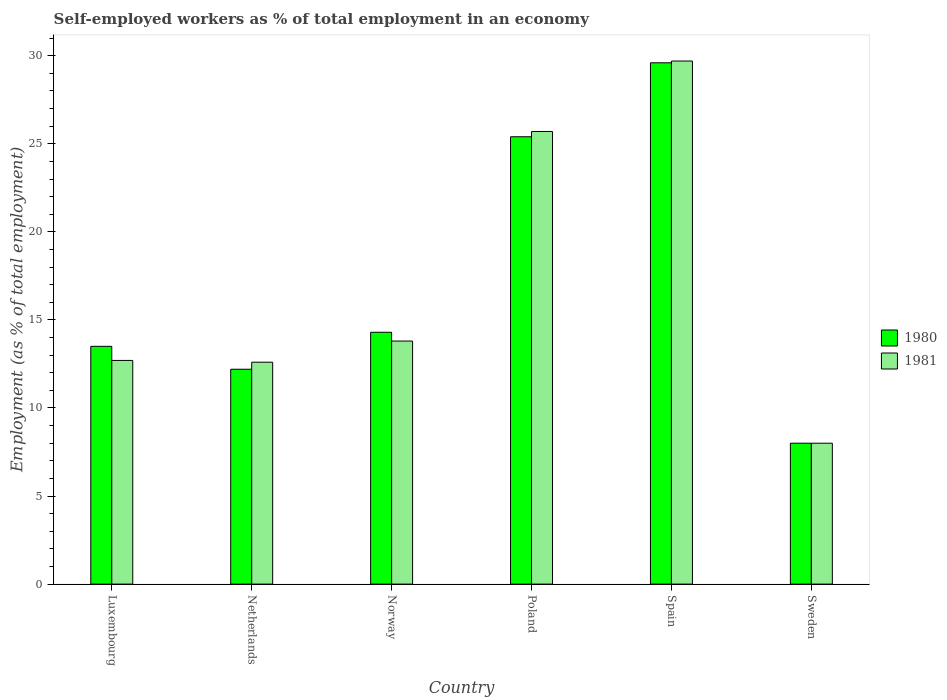How many bars are there on the 5th tick from the right?
Your answer should be compact. 2. In how many cases, is the number of bars for a given country not equal to the number of legend labels?
Give a very brief answer. 0. What is the percentage of self-employed workers in 1980 in Luxembourg?
Provide a succinct answer. 13.5. Across all countries, what is the maximum percentage of self-employed workers in 1981?
Give a very brief answer. 29.7. In which country was the percentage of self-employed workers in 1981 maximum?
Your answer should be very brief. Spain. In which country was the percentage of self-employed workers in 1981 minimum?
Ensure brevity in your answer.  Sweden. What is the total percentage of self-employed workers in 1981 in the graph?
Give a very brief answer. 102.5. What is the difference between the percentage of self-employed workers in 1981 in Luxembourg and that in Norway?
Your answer should be compact. -1.1. What is the difference between the percentage of self-employed workers in 1981 in Netherlands and the percentage of self-employed workers in 1980 in Norway?
Make the answer very short. -1.7. What is the average percentage of self-employed workers in 1980 per country?
Your response must be concise. 17.17. What is the difference between the percentage of self-employed workers of/in 1980 and percentage of self-employed workers of/in 1981 in Poland?
Keep it short and to the point. -0.3. What is the ratio of the percentage of self-employed workers in 1980 in Netherlands to that in Poland?
Your answer should be compact. 0.48. Is the difference between the percentage of self-employed workers in 1980 in Luxembourg and Norway greater than the difference between the percentage of self-employed workers in 1981 in Luxembourg and Norway?
Provide a succinct answer. Yes. What is the difference between the highest and the second highest percentage of self-employed workers in 1981?
Ensure brevity in your answer.  11.9. What is the difference between the highest and the lowest percentage of self-employed workers in 1980?
Offer a very short reply. 21.6. Is the sum of the percentage of self-employed workers in 1981 in Poland and Spain greater than the maximum percentage of self-employed workers in 1980 across all countries?
Provide a short and direct response. Yes. What does the 2nd bar from the left in Norway represents?
Make the answer very short. 1981. Are all the bars in the graph horizontal?
Provide a succinct answer. No. Are the values on the major ticks of Y-axis written in scientific E-notation?
Provide a short and direct response. No. Does the graph contain grids?
Provide a short and direct response. No. How are the legend labels stacked?
Provide a succinct answer. Vertical. What is the title of the graph?
Your answer should be compact. Self-employed workers as % of total employment in an economy. What is the label or title of the X-axis?
Offer a very short reply. Country. What is the label or title of the Y-axis?
Make the answer very short. Employment (as % of total employment). What is the Employment (as % of total employment) in 1980 in Luxembourg?
Give a very brief answer. 13.5. What is the Employment (as % of total employment) of 1981 in Luxembourg?
Ensure brevity in your answer.  12.7. What is the Employment (as % of total employment) of 1980 in Netherlands?
Offer a terse response. 12.2. What is the Employment (as % of total employment) of 1981 in Netherlands?
Offer a very short reply. 12.6. What is the Employment (as % of total employment) of 1980 in Norway?
Your response must be concise. 14.3. What is the Employment (as % of total employment) of 1981 in Norway?
Your response must be concise. 13.8. What is the Employment (as % of total employment) in 1980 in Poland?
Offer a very short reply. 25.4. What is the Employment (as % of total employment) in 1981 in Poland?
Your answer should be very brief. 25.7. What is the Employment (as % of total employment) in 1980 in Spain?
Provide a short and direct response. 29.6. What is the Employment (as % of total employment) of 1981 in Spain?
Offer a terse response. 29.7. What is the Employment (as % of total employment) of 1980 in Sweden?
Give a very brief answer. 8. What is the Employment (as % of total employment) in 1981 in Sweden?
Provide a short and direct response. 8. Across all countries, what is the maximum Employment (as % of total employment) in 1980?
Your response must be concise. 29.6. Across all countries, what is the maximum Employment (as % of total employment) of 1981?
Your response must be concise. 29.7. What is the total Employment (as % of total employment) of 1980 in the graph?
Offer a very short reply. 103. What is the total Employment (as % of total employment) in 1981 in the graph?
Ensure brevity in your answer.  102.5. What is the difference between the Employment (as % of total employment) in 1981 in Luxembourg and that in Netherlands?
Provide a succinct answer. 0.1. What is the difference between the Employment (as % of total employment) of 1980 in Luxembourg and that in Poland?
Keep it short and to the point. -11.9. What is the difference between the Employment (as % of total employment) of 1980 in Luxembourg and that in Spain?
Provide a short and direct response. -16.1. What is the difference between the Employment (as % of total employment) of 1981 in Luxembourg and that in Spain?
Your response must be concise. -17. What is the difference between the Employment (as % of total employment) in 1981 in Luxembourg and that in Sweden?
Offer a very short reply. 4.7. What is the difference between the Employment (as % of total employment) of 1980 in Netherlands and that in Norway?
Give a very brief answer. -2.1. What is the difference between the Employment (as % of total employment) in 1980 in Netherlands and that in Spain?
Your answer should be very brief. -17.4. What is the difference between the Employment (as % of total employment) of 1981 in Netherlands and that in Spain?
Offer a very short reply. -17.1. What is the difference between the Employment (as % of total employment) in 1980 in Norway and that in Spain?
Keep it short and to the point. -15.3. What is the difference between the Employment (as % of total employment) in 1981 in Norway and that in Spain?
Your answer should be compact. -15.9. What is the difference between the Employment (as % of total employment) of 1980 in Norway and that in Sweden?
Give a very brief answer. 6.3. What is the difference between the Employment (as % of total employment) of 1980 in Poland and that in Sweden?
Offer a very short reply. 17.4. What is the difference between the Employment (as % of total employment) in 1980 in Spain and that in Sweden?
Your answer should be very brief. 21.6. What is the difference between the Employment (as % of total employment) in 1981 in Spain and that in Sweden?
Provide a succinct answer. 21.7. What is the difference between the Employment (as % of total employment) in 1980 in Luxembourg and the Employment (as % of total employment) in 1981 in Spain?
Your answer should be very brief. -16.2. What is the difference between the Employment (as % of total employment) of 1980 in Luxembourg and the Employment (as % of total employment) of 1981 in Sweden?
Offer a terse response. 5.5. What is the difference between the Employment (as % of total employment) in 1980 in Netherlands and the Employment (as % of total employment) in 1981 in Norway?
Provide a succinct answer. -1.6. What is the difference between the Employment (as % of total employment) in 1980 in Netherlands and the Employment (as % of total employment) in 1981 in Spain?
Provide a succinct answer. -17.5. What is the difference between the Employment (as % of total employment) of 1980 in Norway and the Employment (as % of total employment) of 1981 in Spain?
Your response must be concise. -15.4. What is the difference between the Employment (as % of total employment) of 1980 in Norway and the Employment (as % of total employment) of 1981 in Sweden?
Keep it short and to the point. 6.3. What is the difference between the Employment (as % of total employment) of 1980 in Poland and the Employment (as % of total employment) of 1981 in Sweden?
Give a very brief answer. 17.4. What is the difference between the Employment (as % of total employment) in 1980 in Spain and the Employment (as % of total employment) in 1981 in Sweden?
Your response must be concise. 21.6. What is the average Employment (as % of total employment) in 1980 per country?
Your answer should be very brief. 17.17. What is the average Employment (as % of total employment) of 1981 per country?
Your answer should be compact. 17.08. What is the difference between the Employment (as % of total employment) in 1980 and Employment (as % of total employment) in 1981 in Poland?
Your response must be concise. -0.3. What is the difference between the Employment (as % of total employment) of 1980 and Employment (as % of total employment) of 1981 in Spain?
Keep it short and to the point. -0.1. What is the difference between the Employment (as % of total employment) in 1980 and Employment (as % of total employment) in 1981 in Sweden?
Ensure brevity in your answer.  0. What is the ratio of the Employment (as % of total employment) in 1980 in Luxembourg to that in Netherlands?
Your answer should be very brief. 1.11. What is the ratio of the Employment (as % of total employment) in 1981 in Luxembourg to that in Netherlands?
Your answer should be compact. 1.01. What is the ratio of the Employment (as % of total employment) of 1980 in Luxembourg to that in Norway?
Your answer should be compact. 0.94. What is the ratio of the Employment (as % of total employment) in 1981 in Luxembourg to that in Norway?
Keep it short and to the point. 0.92. What is the ratio of the Employment (as % of total employment) of 1980 in Luxembourg to that in Poland?
Ensure brevity in your answer.  0.53. What is the ratio of the Employment (as % of total employment) in 1981 in Luxembourg to that in Poland?
Your answer should be compact. 0.49. What is the ratio of the Employment (as % of total employment) in 1980 in Luxembourg to that in Spain?
Make the answer very short. 0.46. What is the ratio of the Employment (as % of total employment) of 1981 in Luxembourg to that in Spain?
Keep it short and to the point. 0.43. What is the ratio of the Employment (as % of total employment) of 1980 in Luxembourg to that in Sweden?
Your response must be concise. 1.69. What is the ratio of the Employment (as % of total employment) of 1981 in Luxembourg to that in Sweden?
Your answer should be very brief. 1.59. What is the ratio of the Employment (as % of total employment) of 1980 in Netherlands to that in Norway?
Offer a very short reply. 0.85. What is the ratio of the Employment (as % of total employment) in 1981 in Netherlands to that in Norway?
Your response must be concise. 0.91. What is the ratio of the Employment (as % of total employment) of 1980 in Netherlands to that in Poland?
Your answer should be very brief. 0.48. What is the ratio of the Employment (as % of total employment) of 1981 in Netherlands to that in Poland?
Your answer should be compact. 0.49. What is the ratio of the Employment (as % of total employment) in 1980 in Netherlands to that in Spain?
Give a very brief answer. 0.41. What is the ratio of the Employment (as % of total employment) of 1981 in Netherlands to that in Spain?
Offer a terse response. 0.42. What is the ratio of the Employment (as % of total employment) of 1980 in Netherlands to that in Sweden?
Ensure brevity in your answer.  1.52. What is the ratio of the Employment (as % of total employment) of 1981 in Netherlands to that in Sweden?
Give a very brief answer. 1.57. What is the ratio of the Employment (as % of total employment) in 1980 in Norway to that in Poland?
Offer a terse response. 0.56. What is the ratio of the Employment (as % of total employment) of 1981 in Norway to that in Poland?
Provide a short and direct response. 0.54. What is the ratio of the Employment (as % of total employment) of 1980 in Norway to that in Spain?
Make the answer very short. 0.48. What is the ratio of the Employment (as % of total employment) in 1981 in Norway to that in Spain?
Provide a short and direct response. 0.46. What is the ratio of the Employment (as % of total employment) of 1980 in Norway to that in Sweden?
Offer a terse response. 1.79. What is the ratio of the Employment (as % of total employment) in 1981 in Norway to that in Sweden?
Keep it short and to the point. 1.73. What is the ratio of the Employment (as % of total employment) in 1980 in Poland to that in Spain?
Make the answer very short. 0.86. What is the ratio of the Employment (as % of total employment) of 1981 in Poland to that in Spain?
Keep it short and to the point. 0.87. What is the ratio of the Employment (as % of total employment) in 1980 in Poland to that in Sweden?
Offer a terse response. 3.17. What is the ratio of the Employment (as % of total employment) of 1981 in Poland to that in Sweden?
Your response must be concise. 3.21. What is the ratio of the Employment (as % of total employment) in 1980 in Spain to that in Sweden?
Your answer should be very brief. 3.7. What is the ratio of the Employment (as % of total employment) in 1981 in Spain to that in Sweden?
Offer a terse response. 3.71. What is the difference between the highest and the lowest Employment (as % of total employment) in 1980?
Provide a short and direct response. 21.6. What is the difference between the highest and the lowest Employment (as % of total employment) of 1981?
Offer a terse response. 21.7. 